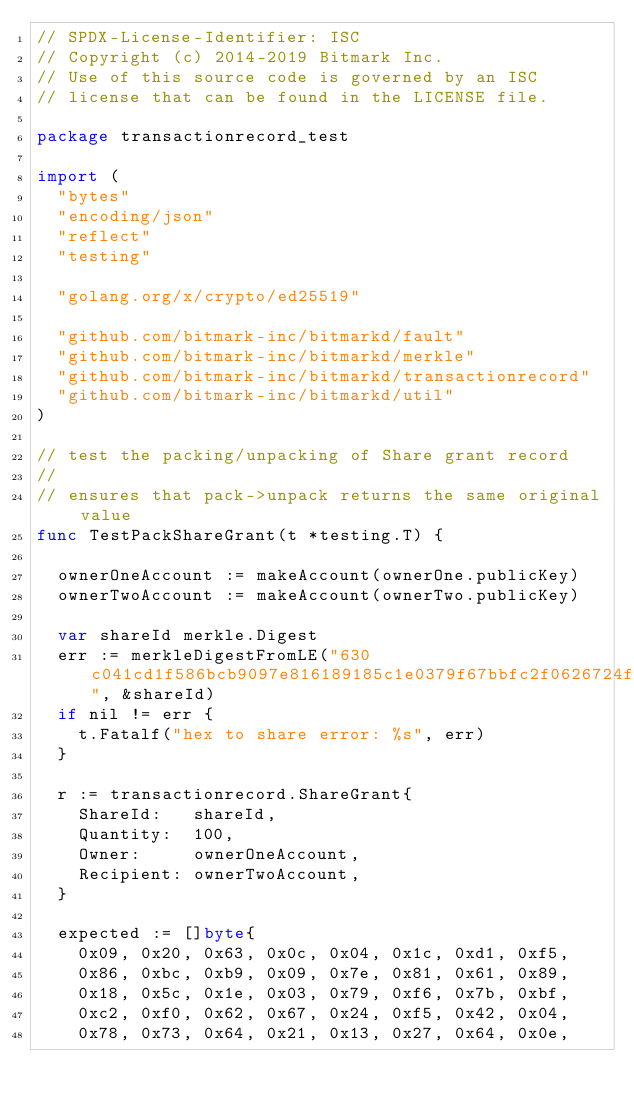Convert code to text. <code><loc_0><loc_0><loc_500><loc_500><_Go_>// SPDX-License-Identifier: ISC
// Copyright (c) 2014-2019 Bitmark Inc.
// Use of this source code is governed by an ISC
// license that can be found in the LICENSE file.

package transactionrecord_test

import (
	"bytes"
	"encoding/json"
	"reflect"
	"testing"

	"golang.org/x/crypto/ed25519"

	"github.com/bitmark-inc/bitmarkd/fault"
	"github.com/bitmark-inc/bitmarkd/merkle"
	"github.com/bitmark-inc/bitmarkd/transactionrecord"
	"github.com/bitmark-inc/bitmarkd/util"
)

// test the packing/unpacking of Share grant record
//
// ensures that pack->unpack returns the same original value
func TestPackShareGrant(t *testing.T) {

	ownerOneAccount := makeAccount(ownerOne.publicKey)
	ownerTwoAccount := makeAccount(ownerTwo.publicKey)

	var shareId merkle.Digest
	err := merkleDigestFromLE("630c041cd1f586bcb9097e816189185c1e0379f67bbfc2f0626724f542047873", &shareId)
	if nil != err {
		t.Fatalf("hex to share error: %s", err)
	}

	r := transactionrecord.ShareGrant{
		ShareId:   shareId,
		Quantity:  100,
		Owner:     ownerOneAccount,
		Recipient: ownerTwoAccount,
	}

	expected := []byte{
		0x09, 0x20, 0x63, 0x0c, 0x04, 0x1c, 0xd1, 0xf5,
		0x86, 0xbc, 0xb9, 0x09, 0x7e, 0x81, 0x61, 0x89,
		0x18, 0x5c, 0x1e, 0x03, 0x79, 0xf6, 0x7b, 0xbf,
		0xc2, 0xf0, 0x62, 0x67, 0x24, 0xf5, 0x42, 0x04,
		0x78, 0x73, 0x64, 0x21, 0x13, 0x27, 0x64, 0x0e,</code> 